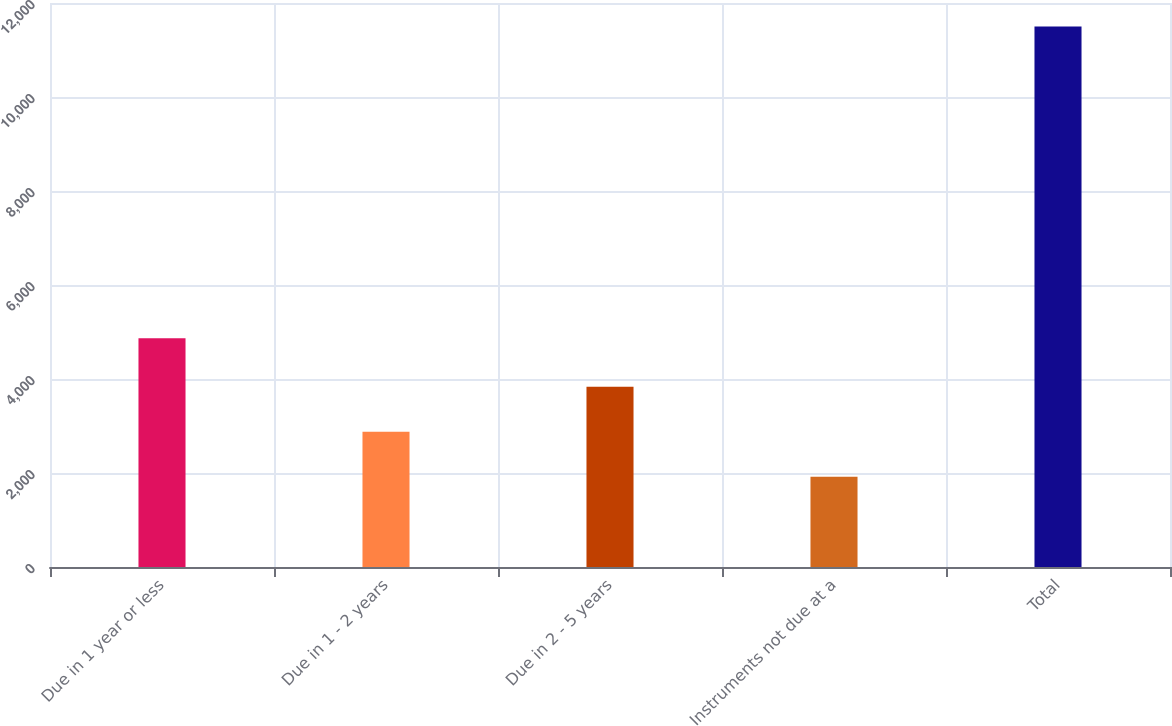Convert chart to OTSL. <chart><loc_0><loc_0><loc_500><loc_500><bar_chart><fcel>Due in 1 year or less<fcel>Due in 1 - 2 years<fcel>Due in 2 - 5 years<fcel>Instruments not due at a<fcel>Total<nl><fcel>4866<fcel>2878.2<fcel>3836.4<fcel>1920<fcel>11502<nl></chart> 